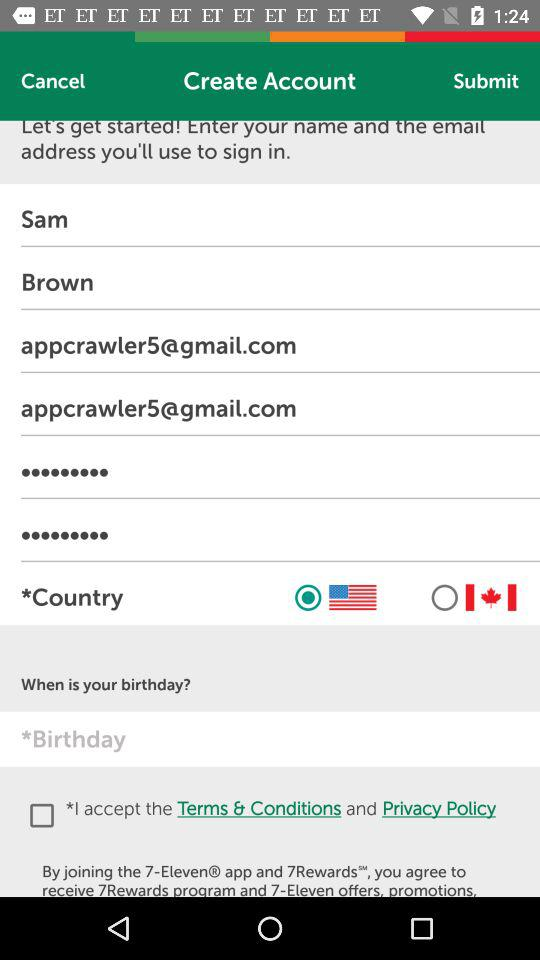What is the selected country? The selected country is the United States. 